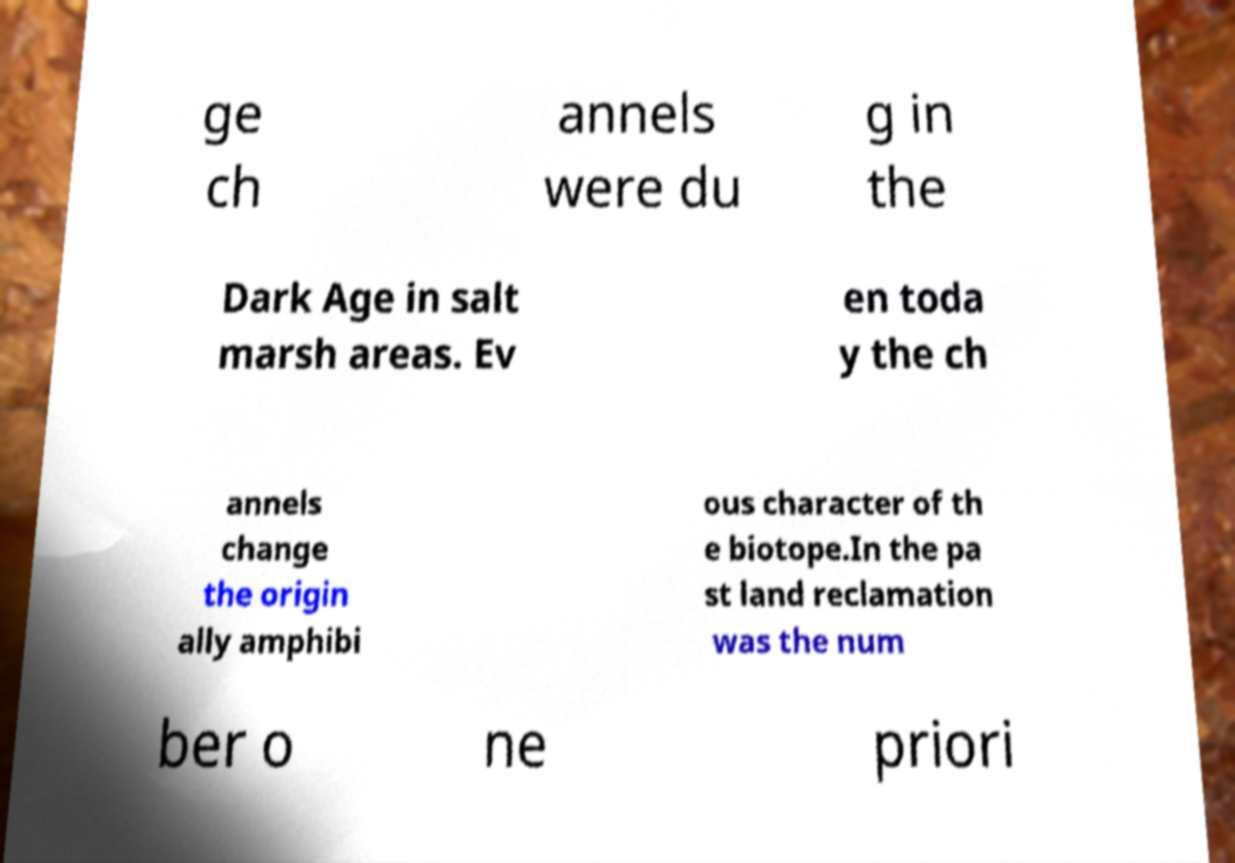What messages or text are displayed in this image? I need them in a readable, typed format. ge ch annels were du g in the Dark Age in salt marsh areas. Ev en toda y the ch annels change the origin ally amphibi ous character of th e biotope.In the pa st land reclamation was the num ber o ne priori 